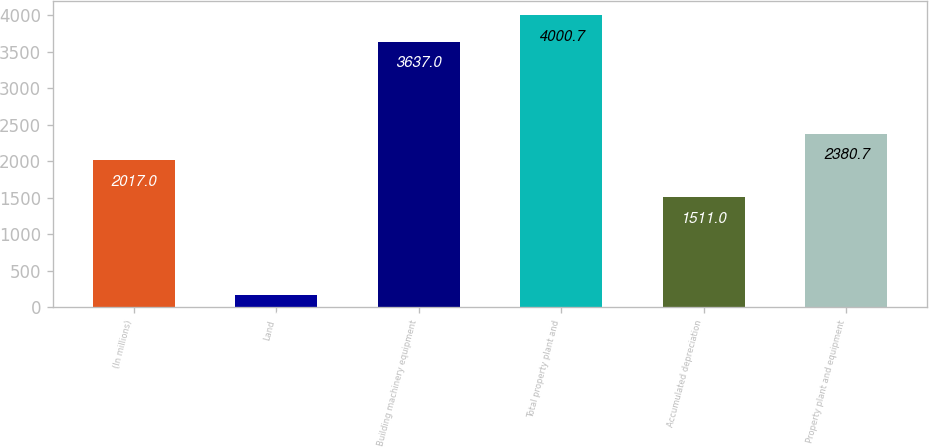<chart> <loc_0><loc_0><loc_500><loc_500><bar_chart><fcel>(In millions)<fcel>Land<fcel>Building machinery equipment<fcel>Total property plant and<fcel>Accumulated depreciation<fcel>Property plant and equipment<nl><fcel>2017<fcel>166<fcel>3637<fcel>4000.7<fcel>1511<fcel>2380.7<nl></chart> 